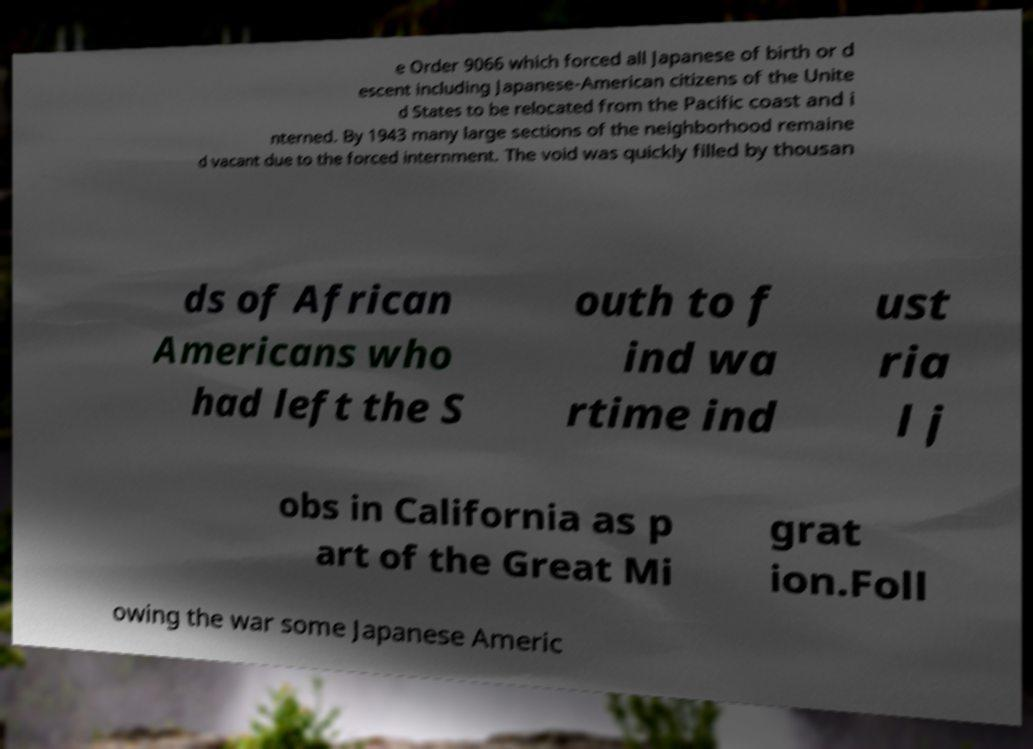Can you accurately transcribe the text from the provided image for me? e Order 9066 which forced all Japanese of birth or d escent including Japanese-American citizens of the Unite d States to be relocated from the Pacific coast and i nterned. By 1943 many large sections of the neighborhood remaine d vacant due to the forced internment. The void was quickly filled by thousan ds of African Americans who had left the S outh to f ind wa rtime ind ust ria l j obs in California as p art of the Great Mi grat ion.Foll owing the war some Japanese Americ 